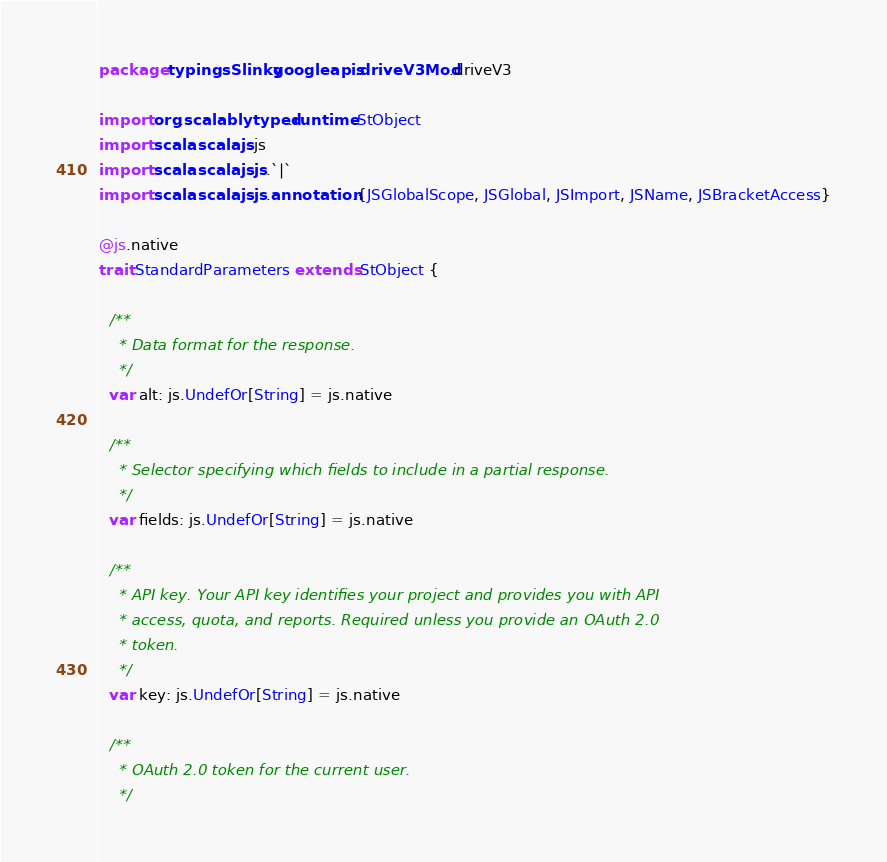Convert code to text. <code><loc_0><loc_0><loc_500><loc_500><_Scala_>package typingsSlinky.googleapis.driveV3Mod.driveV3

import org.scalablytyped.runtime.StObject
import scala.scalajs.js
import scala.scalajs.js.`|`
import scala.scalajs.js.annotation.{JSGlobalScope, JSGlobal, JSImport, JSName, JSBracketAccess}

@js.native
trait StandardParameters extends StObject {
  
  /**
    * Data format for the response.
    */
  var alt: js.UndefOr[String] = js.native
  
  /**
    * Selector specifying which fields to include in a partial response.
    */
  var fields: js.UndefOr[String] = js.native
  
  /**
    * API key. Your API key identifies your project and provides you with API
    * access, quota, and reports. Required unless you provide an OAuth 2.0
    * token.
    */
  var key: js.UndefOr[String] = js.native
  
  /**
    * OAuth 2.0 token for the current user.
    */</code> 